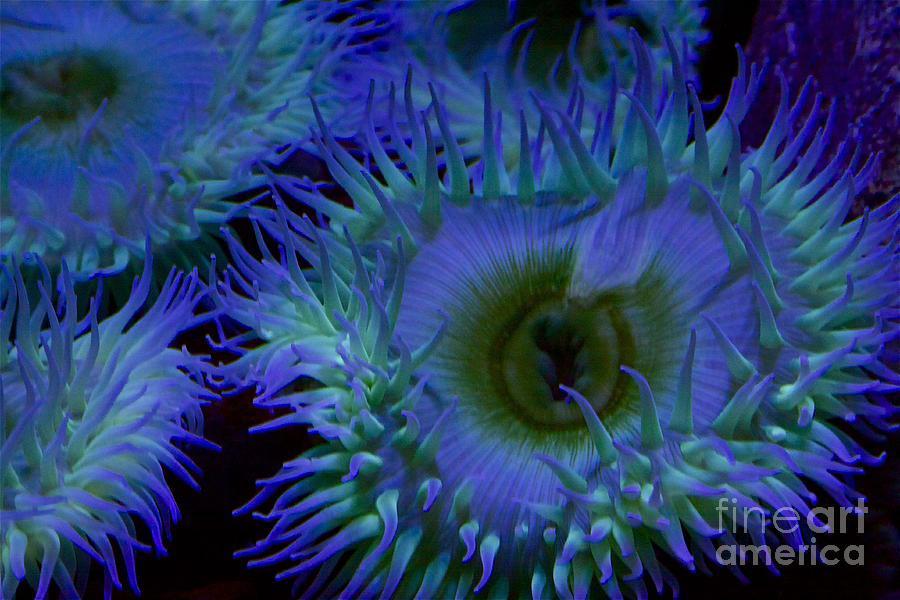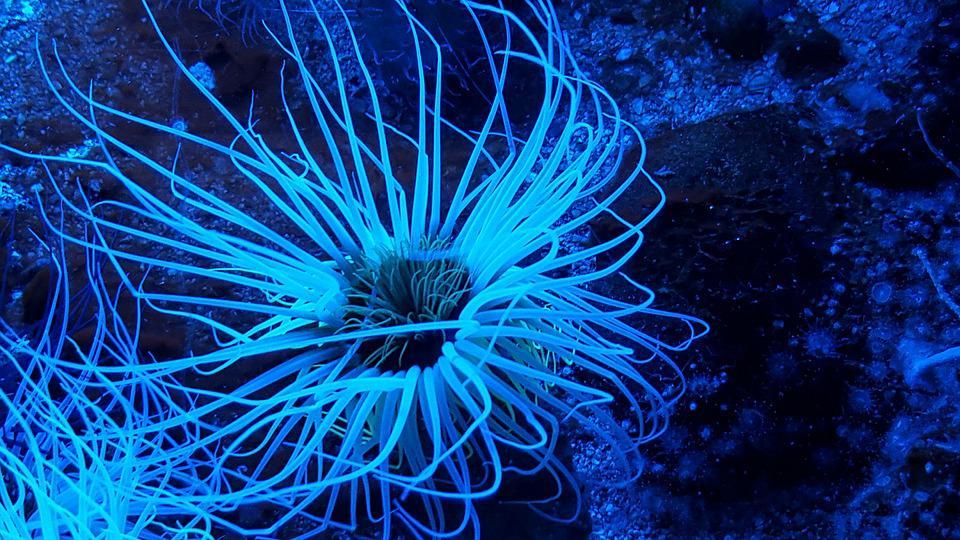The first image is the image on the left, the second image is the image on the right. Examine the images to the left and right. Is the description "A sea anemone is a solid color pink and there are no fish swimming around it." accurate? Answer yes or no. No. The first image is the image on the left, the second image is the image on the right. Evaluate the accuracy of this statement regarding the images: "A flower-shaped anemone has solid-colored, tapered, pinkish-lavender tendrils, with no fish swimming among them.". Is it true? Answer yes or no. No. 